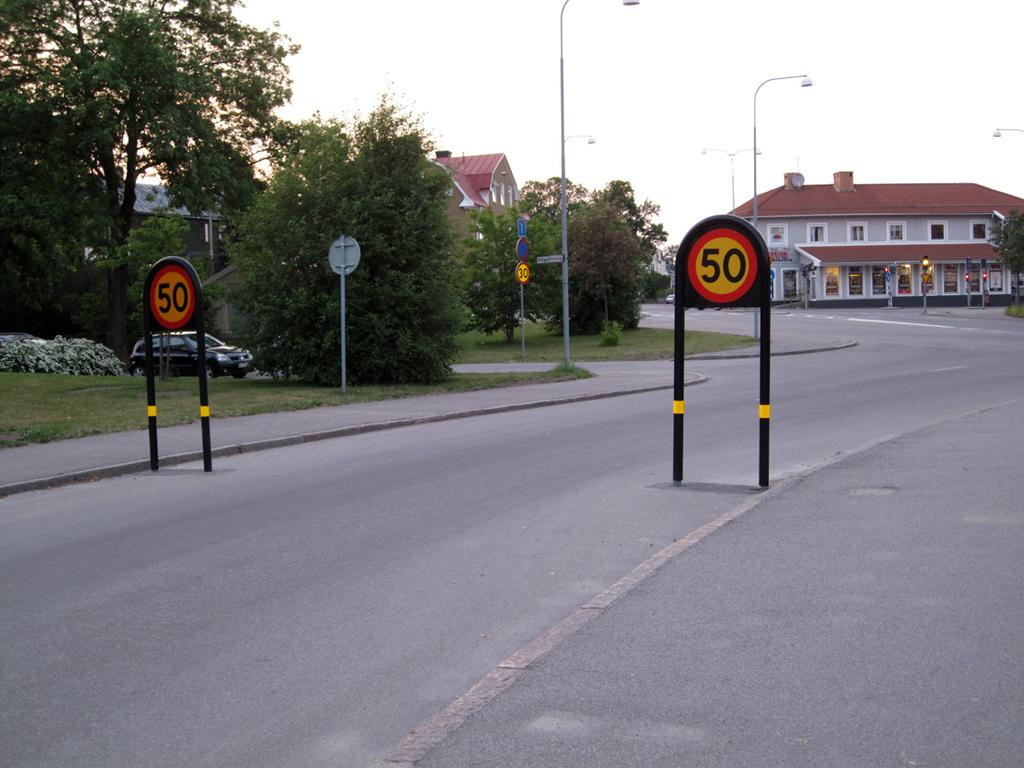<image>
Give a short and clear explanation of the subsequent image. the number 50 that is on a sign outdoors 